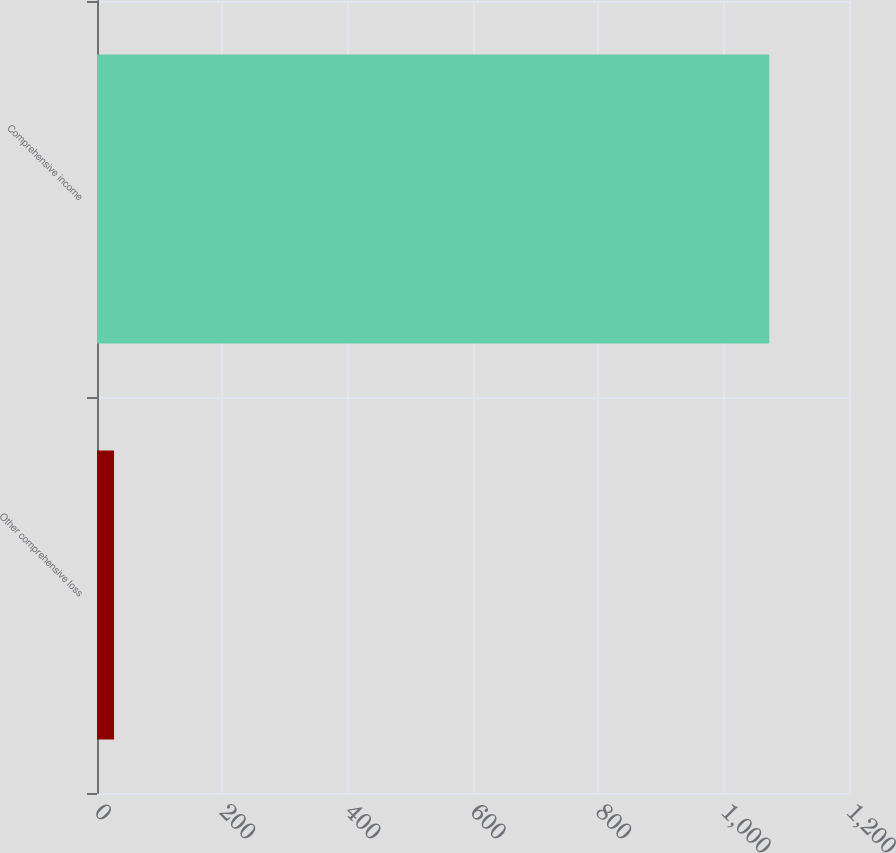Convert chart. <chart><loc_0><loc_0><loc_500><loc_500><bar_chart><fcel>Other comprehensive loss<fcel>Comprehensive income<nl><fcel>27.2<fcel>1072.8<nl></chart> 